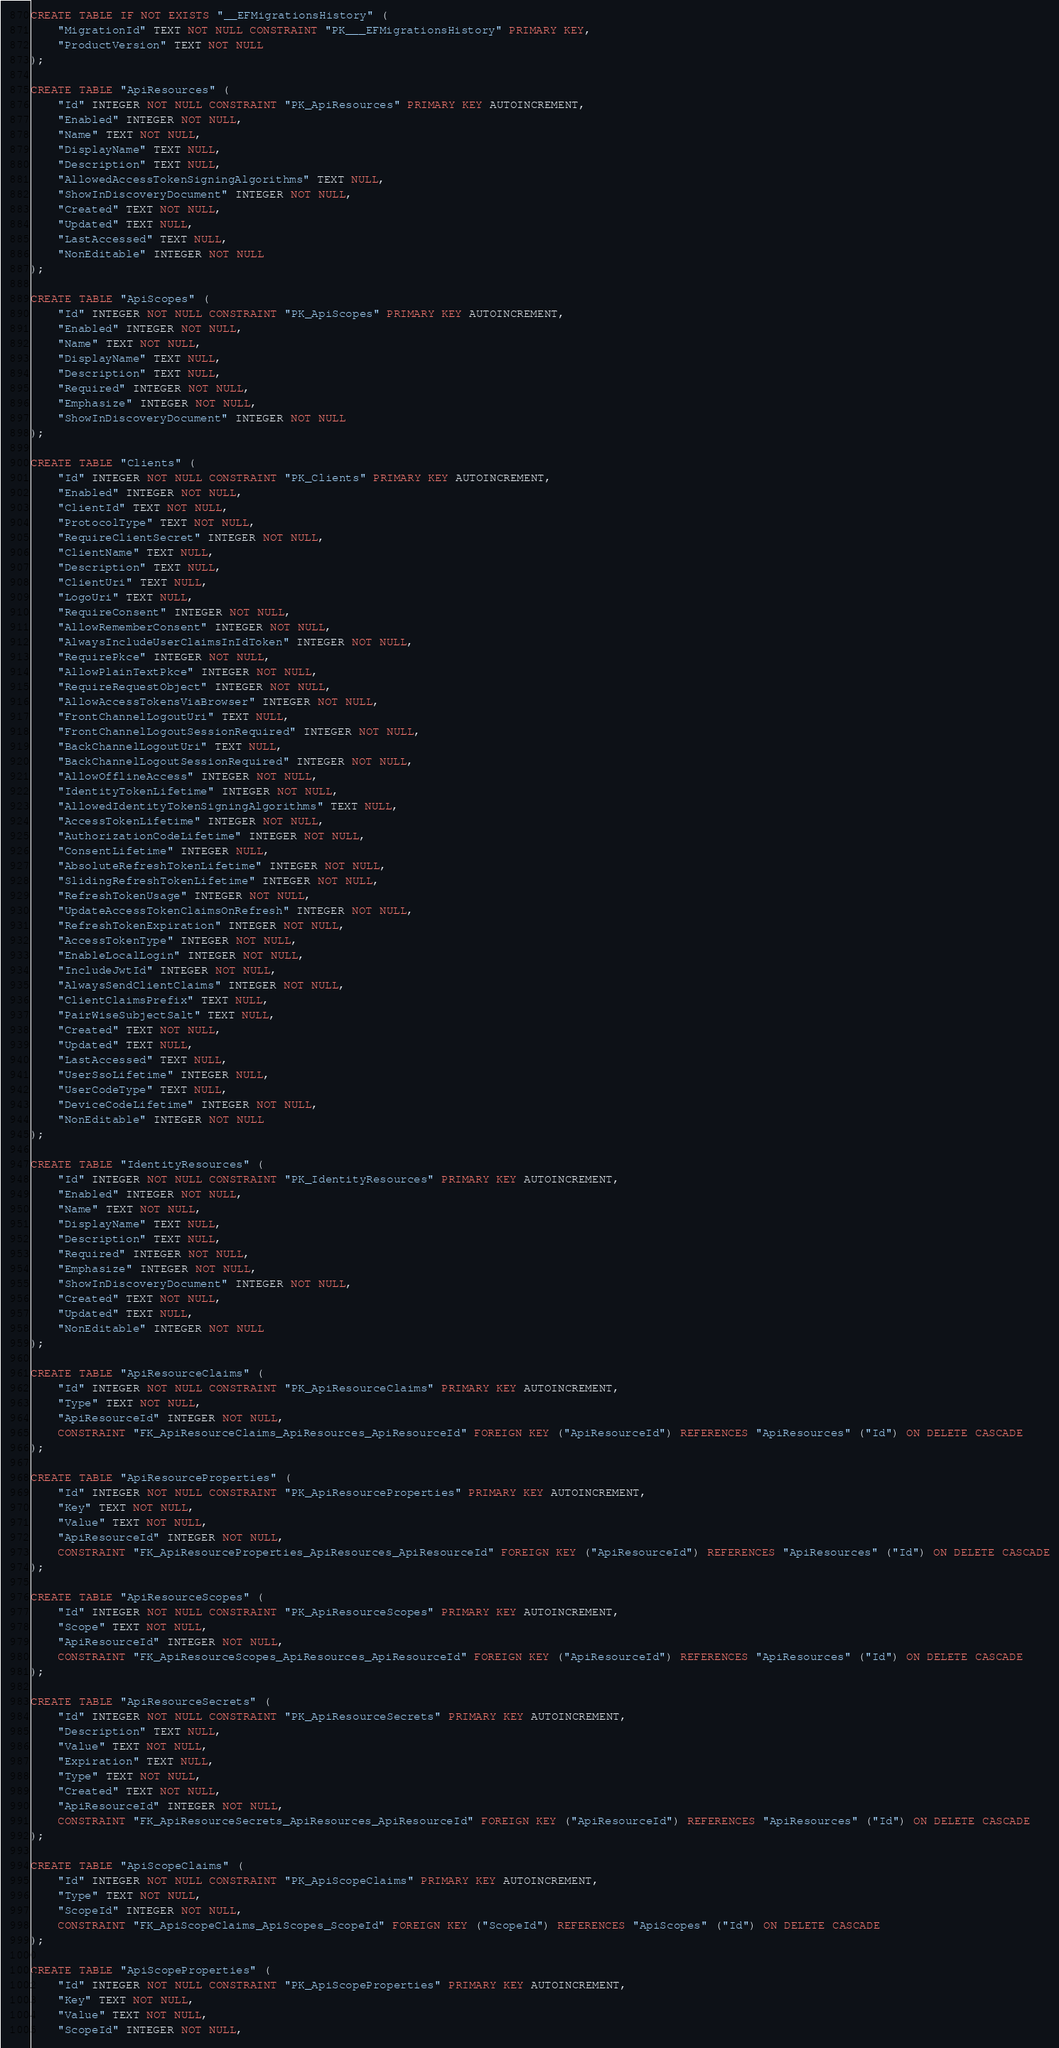<code> <loc_0><loc_0><loc_500><loc_500><_SQL_>CREATE TABLE IF NOT EXISTS "__EFMigrationsHistory" (
    "MigrationId" TEXT NOT NULL CONSTRAINT "PK___EFMigrationsHistory" PRIMARY KEY,
    "ProductVersion" TEXT NOT NULL
);

CREATE TABLE "ApiResources" (
    "Id" INTEGER NOT NULL CONSTRAINT "PK_ApiResources" PRIMARY KEY AUTOINCREMENT,
    "Enabled" INTEGER NOT NULL,
    "Name" TEXT NOT NULL,
    "DisplayName" TEXT NULL,
    "Description" TEXT NULL,
    "AllowedAccessTokenSigningAlgorithms" TEXT NULL,
    "ShowInDiscoveryDocument" INTEGER NOT NULL,
    "Created" TEXT NOT NULL,
    "Updated" TEXT NULL,
    "LastAccessed" TEXT NULL,
    "NonEditable" INTEGER NOT NULL
);

CREATE TABLE "ApiScopes" (
    "Id" INTEGER NOT NULL CONSTRAINT "PK_ApiScopes" PRIMARY KEY AUTOINCREMENT,
    "Enabled" INTEGER NOT NULL,
    "Name" TEXT NOT NULL,
    "DisplayName" TEXT NULL,
    "Description" TEXT NULL,
    "Required" INTEGER NOT NULL,
    "Emphasize" INTEGER NOT NULL,
    "ShowInDiscoveryDocument" INTEGER NOT NULL
);

CREATE TABLE "Clients" (
    "Id" INTEGER NOT NULL CONSTRAINT "PK_Clients" PRIMARY KEY AUTOINCREMENT,
    "Enabled" INTEGER NOT NULL,
    "ClientId" TEXT NOT NULL,
    "ProtocolType" TEXT NOT NULL,
    "RequireClientSecret" INTEGER NOT NULL,
    "ClientName" TEXT NULL,
    "Description" TEXT NULL,
    "ClientUri" TEXT NULL,
    "LogoUri" TEXT NULL,
    "RequireConsent" INTEGER NOT NULL,
    "AllowRememberConsent" INTEGER NOT NULL,
    "AlwaysIncludeUserClaimsInIdToken" INTEGER NOT NULL,
    "RequirePkce" INTEGER NOT NULL,
    "AllowPlainTextPkce" INTEGER NOT NULL,
    "RequireRequestObject" INTEGER NOT NULL,
    "AllowAccessTokensViaBrowser" INTEGER NOT NULL,
    "FrontChannelLogoutUri" TEXT NULL,
    "FrontChannelLogoutSessionRequired" INTEGER NOT NULL,
    "BackChannelLogoutUri" TEXT NULL,
    "BackChannelLogoutSessionRequired" INTEGER NOT NULL,
    "AllowOfflineAccess" INTEGER NOT NULL,
    "IdentityTokenLifetime" INTEGER NOT NULL,
    "AllowedIdentityTokenSigningAlgorithms" TEXT NULL,
    "AccessTokenLifetime" INTEGER NOT NULL,
    "AuthorizationCodeLifetime" INTEGER NOT NULL,
    "ConsentLifetime" INTEGER NULL,
    "AbsoluteRefreshTokenLifetime" INTEGER NOT NULL,
    "SlidingRefreshTokenLifetime" INTEGER NOT NULL,
    "RefreshTokenUsage" INTEGER NOT NULL,
    "UpdateAccessTokenClaimsOnRefresh" INTEGER NOT NULL,
    "RefreshTokenExpiration" INTEGER NOT NULL,
    "AccessTokenType" INTEGER NOT NULL,
    "EnableLocalLogin" INTEGER NOT NULL,
    "IncludeJwtId" INTEGER NOT NULL,
    "AlwaysSendClientClaims" INTEGER NOT NULL,
    "ClientClaimsPrefix" TEXT NULL,
    "PairWiseSubjectSalt" TEXT NULL,
    "Created" TEXT NOT NULL,
    "Updated" TEXT NULL,
    "LastAccessed" TEXT NULL,
    "UserSsoLifetime" INTEGER NULL,
    "UserCodeType" TEXT NULL,
    "DeviceCodeLifetime" INTEGER NOT NULL,
    "NonEditable" INTEGER NOT NULL
);

CREATE TABLE "IdentityResources" (
    "Id" INTEGER NOT NULL CONSTRAINT "PK_IdentityResources" PRIMARY KEY AUTOINCREMENT,
    "Enabled" INTEGER NOT NULL,
    "Name" TEXT NOT NULL,
    "DisplayName" TEXT NULL,
    "Description" TEXT NULL,
    "Required" INTEGER NOT NULL,
    "Emphasize" INTEGER NOT NULL,
    "ShowInDiscoveryDocument" INTEGER NOT NULL,
    "Created" TEXT NOT NULL,
    "Updated" TEXT NULL,
    "NonEditable" INTEGER NOT NULL
);

CREATE TABLE "ApiResourceClaims" (
    "Id" INTEGER NOT NULL CONSTRAINT "PK_ApiResourceClaims" PRIMARY KEY AUTOINCREMENT,
    "Type" TEXT NOT NULL,
    "ApiResourceId" INTEGER NOT NULL,
    CONSTRAINT "FK_ApiResourceClaims_ApiResources_ApiResourceId" FOREIGN KEY ("ApiResourceId") REFERENCES "ApiResources" ("Id") ON DELETE CASCADE
);

CREATE TABLE "ApiResourceProperties" (
    "Id" INTEGER NOT NULL CONSTRAINT "PK_ApiResourceProperties" PRIMARY KEY AUTOINCREMENT,
    "Key" TEXT NOT NULL,
    "Value" TEXT NOT NULL,
    "ApiResourceId" INTEGER NOT NULL,
    CONSTRAINT "FK_ApiResourceProperties_ApiResources_ApiResourceId" FOREIGN KEY ("ApiResourceId") REFERENCES "ApiResources" ("Id") ON DELETE CASCADE
);

CREATE TABLE "ApiResourceScopes" (
    "Id" INTEGER NOT NULL CONSTRAINT "PK_ApiResourceScopes" PRIMARY KEY AUTOINCREMENT,
    "Scope" TEXT NOT NULL,
    "ApiResourceId" INTEGER NOT NULL,
    CONSTRAINT "FK_ApiResourceScopes_ApiResources_ApiResourceId" FOREIGN KEY ("ApiResourceId") REFERENCES "ApiResources" ("Id") ON DELETE CASCADE
);

CREATE TABLE "ApiResourceSecrets" (
    "Id" INTEGER NOT NULL CONSTRAINT "PK_ApiResourceSecrets" PRIMARY KEY AUTOINCREMENT,
    "Description" TEXT NULL,
    "Value" TEXT NOT NULL,
    "Expiration" TEXT NULL,
    "Type" TEXT NOT NULL,
    "Created" TEXT NOT NULL,
    "ApiResourceId" INTEGER NOT NULL,
    CONSTRAINT "FK_ApiResourceSecrets_ApiResources_ApiResourceId" FOREIGN KEY ("ApiResourceId") REFERENCES "ApiResources" ("Id") ON DELETE CASCADE
);

CREATE TABLE "ApiScopeClaims" (
    "Id" INTEGER NOT NULL CONSTRAINT "PK_ApiScopeClaims" PRIMARY KEY AUTOINCREMENT,
    "Type" TEXT NOT NULL,
    "ScopeId" INTEGER NOT NULL,
    CONSTRAINT "FK_ApiScopeClaims_ApiScopes_ScopeId" FOREIGN KEY ("ScopeId") REFERENCES "ApiScopes" ("Id") ON DELETE CASCADE
);

CREATE TABLE "ApiScopeProperties" (
    "Id" INTEGER NOT NULL CONSTRAINT "PK_ApiScopeProperties" PRIMARY KEY AUTOINCREMENT,
    "Key" TEXT NOT NULL,
    "Value" TEXT NOT NULL,
    "ScopeId" INTEGER NOT NULL,</code> 